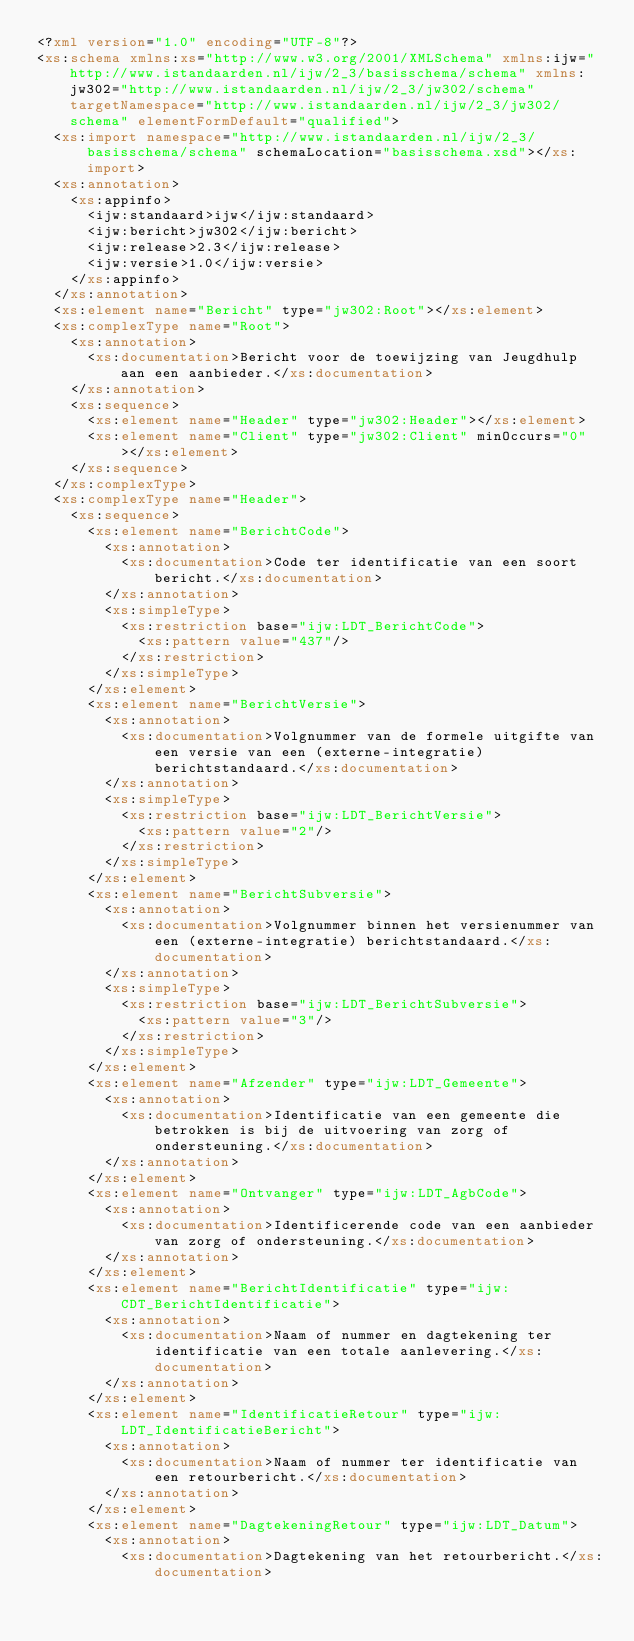Convert code to text. <code><loc_0><loc_0><loc_500><loc_500><_XML_><?xml version="1.0" encoding="UTF-8"?>
<xs:schema xmlns:xs="http://www.w3.org/2001/XMLSchema" xmlns:ijw="http://www.istandaarden.nl/ijw/2_3/basisschema/schema" xmlns:jw302="http://www.istandaarden.nl/ijw/2_3/jw302/schema" targetNamespace="http://www.istandaarden.nl/ijw/2_3/jw302/schema" elementFormDefault="qualified">
	<xs:import namespace="http://www.istandaarden.nl/ijw/2_3/basisschema/schema" schemaLocation="basisschema.xsd"></xs:import>
	<xs:annotation>
		<xs:appinfo>
			<ijw:standaard>ijw</ijw:standaard>
			<ijw:bericht>jw302</ijw:bericht>
			<ijw:release>2.3</ijw:release>
			<ijw:versie>1.0</ijw:versie>
		</xs:appinfo>
	</xs:annotation>
	<xs:element name="Bericht" type="jw302:Root"></xs:element>
	<xs:complexType name="Root">
		<xs:annotation>
			<xs:documentation>Bericht voor de toewijzing van Jeugdhulp aan een aanbieder.</xs:documentation>
		</xs:annotation>
		<xs:sequence>
			<xs:element name="Header" type="jw302:Header"></xs:element>
			<xs:element name="Client" type="jw302:Client" minOccurs="0"></xs:element>
		</xs:sequence>
	</xs:complexType>
	<xs:complexType name="Header">
		<xs:sequence>
			<xs:element name="BerichtCode">
				<xs:annotation>
					<xs:documentation>Code ter identificatie van een soort bericht.</xs:documentation>
				</xs:annotation>
				<xs:simpleType>
					<xs:restriction base="ijw:LDT_BerichtCode">
						<xs:pattern value="437"/>
					</xs:restriction>
				</xs:simpleType>
			</xs:element>
			<xs:element name="BerichtVersie">
				<xs:annotation>
					<xs:documentation>Volgnummer van de formele uitgifte van een versie van een (externe-integratie) berichtstandaard.</xs:documentation>
				</xs:annotation>
				<xs:simpleType>
					<xs:restriction base="ijw:LDT_BerichtVersie">
						<xs:pattern value="2"/>
					</xs:restriction>
				</xs:simpleType>
			</xs:element>
			<xs:element name="BerichtSubversie">
				<xs:annotation>
					<xs:documentation>Volgnummer binnen het versienummer van een (externe-integratie) berichtstandaard.</xs:documentation>
				</xs:annotation>
				<xs:simpleType>
					<xs:restriction base="ijw:LDT_BerichtSubversie">
						<xs:pattern value="3"/>
					</xs:restriction>
				</xs:simpleType>
			</xs:element>
			<xs:element name="Afzender" type="ijw:LDT_Gemeente">
				<xs:annotation>
					<xs:documentation>Identificatie van een gemeente die betrokken is bij de uitvoering van zorg of ondersteuning.</xs:documentation>
				</xs:annotation>
			</xs:element>
			<xs:element name="Ontvanger" type="ijw:LDT_AgbCode">
				<xs:annotation>
					<xs:documentation>Identificerende code van een aanbieder van zorg of ondersteuning.</xs:documentation>
				</xs:annotation>
			</xs:element>
			<xs:element name="BerichtIdentificatie" type="ijw:CDT_BerichtIdentificatie">
				<xs:annotation>
					<xs:documentation>Naam of nummer en dagtekening ter identificatie van een totale aanlevering.</xs:documentation>
				</xs:annotation>
			</xs:element>
			<xs:element name="IdentificatieRetour" type="ijw:LDT_IdentificatieBericht">
				<xs:annotation>
					<xs:documentation>Naam of nummer ter identificatie van een retourbericht.</xs:documentation>
				</xs:annotation>
			</xs:element>
			<xs:element name="DagtekeningRetour" type="ijw:LDT_Datum">
				<xs:annotation>
					<xs:documentation>Dagtekening van het retourbericht.</xs:documentation></code> 